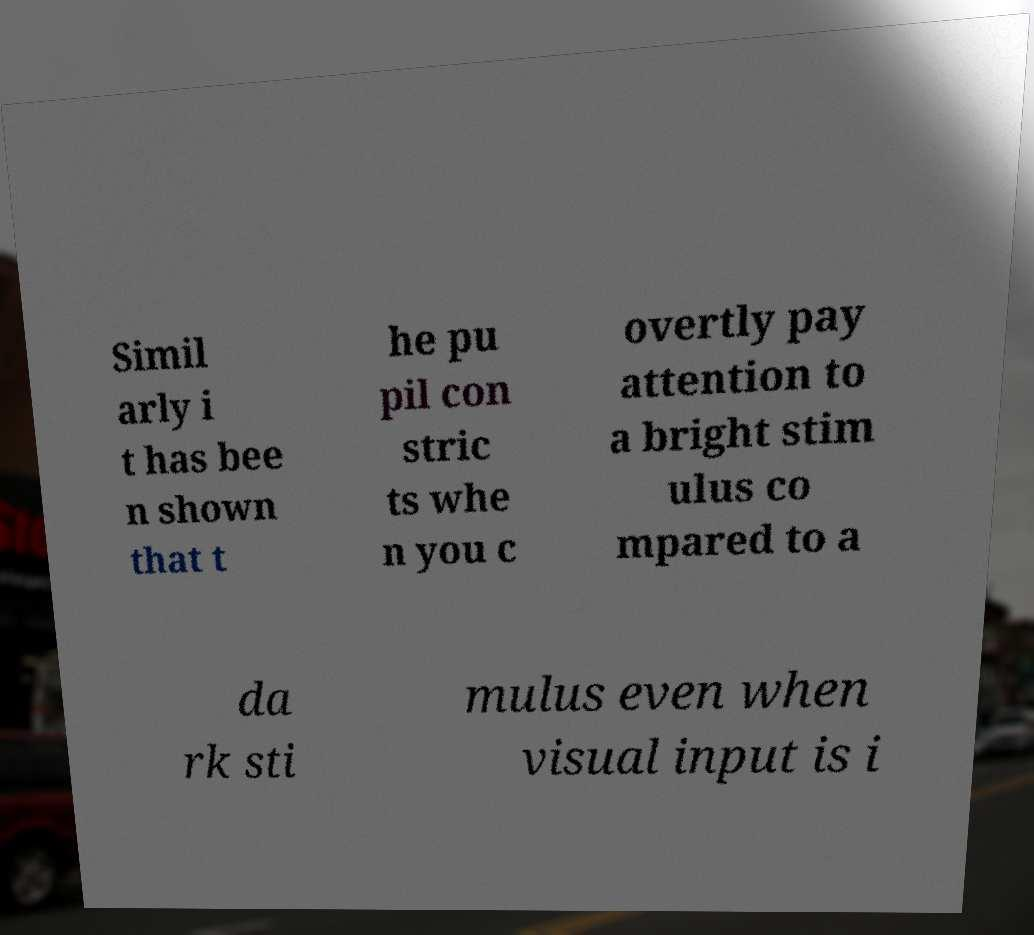What messages or text are displayed in this image? I need them in a readable, typed format. Simil arly i t has bee n shown that t he pu pil con stric ts whe n you c overtly pay attention to a bright stim ulus co mpared to a da rk sti mulus even when visual input is i 